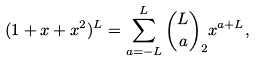<formula> <loc_0><loc_0><loc_500><loc_500>( 1 + x + x ^ { 2 } ) ^ { L } = \sum _ { a = - L } ^ { L } \binom { L } { a } _ { 2 } x ^ { a + L } ,</formula> 